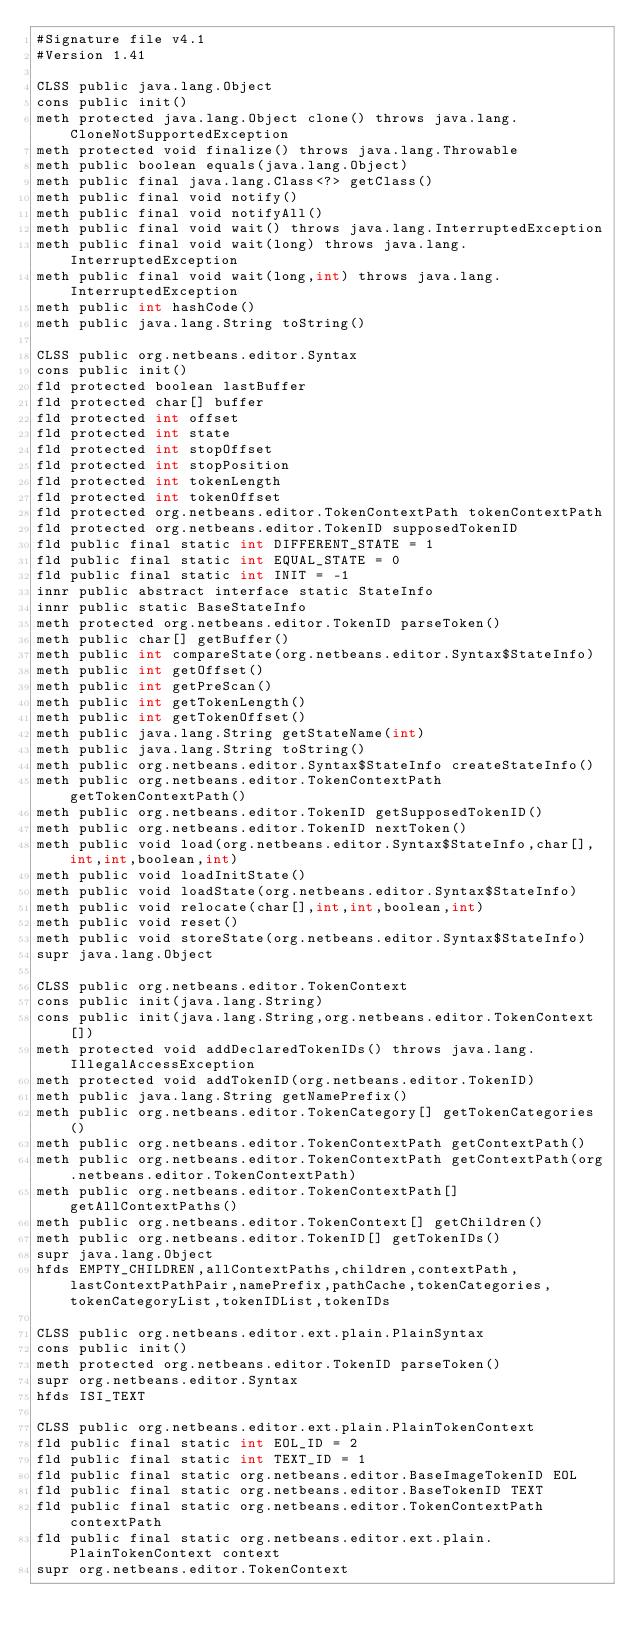Convert code to text. <code><loc_0><loc_0><loc_500><loc_500><_SML_>#Signature file v4.1
#Version 1.41

CLSS public java.lang.Object
cons public init()
meth protected java.lang.Object clone() throws java.lang.CloneNotSupportedException
meth protected void finalize() throws java.lang.Throwable
meth public boolean equals(java.lang.Object)
meth public final java.lang.Class<?> getClass()
meth public final void notify()
meth public final void notifyAll()
meth public final void wait() throws java.lang.InterruptedException
meth public final void wait(long) throws java.lang.InterruptedException
meth public final void wait(long,int) throws java.lang.InterruptedException
meth public int hashCode()
meth public java.lang.String toString()

CLSS public org.netbeans.editor.Syntax
cons public init()
fld protected boolean lastBuffer
fld protected char[] buffer
fld protected int offset
fld protected int state
fld protected int stopOffset
fld protected int stopPosition
fld protected int tokenLength
fld protected int tokenOffset
fld protected org.netbeans.editor.TokenContextPath tokenContextPath
fld protected org.netbeans.editor.TokenID supposedTokenID
fld public final static int DIFFERENT_STATE = 1
fld public final static int EQUAL_STATE = 0
fld public final static int INIT = -1
innr public abstract interface static StateInfo
innr public static BaseStateInfo
meth protected org.netbeans.editor.TokenID parseToken()
meth public char[] getBuffer()
meth public int compareState(org.netbeans.editor.Syntax$StateInfo)
meth public int getOffset()
meth public int getPreScan()
meth public int getTokenLength()
meth public int getTokenOffset()
meth public java.lang.String getStateName(int)
meth public java.lang.String toString()
meth public org.netbeans.editor.Syntax$StateInfo createStateInfo()
meth public org.netbeans.editor.TokenContextPath getTokenContextPath()
meth public org.netbeans.editor.TokenID getSupposedTokenID()
meth public org.netbeans.editor.TokenID nextToken()
meth public void load(org.netbeans.editor.Syntax$StateInfo,char[],int,int,boolean,int)
meth public void loadInitState()
meth public void loadState(org.netbeans.editor.Syntax$StateInfo)
meth public void relocate(char[],int,int,boolean,int)
meth public void reset()
meth public void storeState(org.netbeans.editor.Syntax$StateInfo)
supr java.lang.Object

CLSS public org.netbeans.editor.TokenContext
cons public init(java.lang.String)
cons public init(java.lang.String,org.netbeans.editor.TokenContext[])
meth protected void addDeclaredTokenIDs() throws java.lang.IllegalAccessException
meth protected void addTokenID(org.netbeans.editor.TokenID)
meth public java.lang.String getNamePrefix()
meth public org.netbeans.editor.TokenCategory[] getTokenCategories()
meth public org.netbeans.editor.TokenContextPath getContextPath()
meth public org.netbeans.editor.TokenContextPath getContextPath(org.netbeans.editor.TokenContextPath)
meth public org.netbeans.editor.TokenContextPath[] getAllContextPaths()
meth public org.netbeans.editor.TokenContext[] getChildren()
meth public org.netbeans.editor.TokenID[] getTokenIDs()
supr java.lang.Object
hfds EMPTY_CHILDREN,allContextPaths,children,contextPath,lastContextPathPair,namePrefix,pathCache,tokenCategories,tokenCategoryList,tokenIDList,tokenIDs

CLSS public org.netbeans.editor.ext.plain.PlainSyntax
cons public init()
meth protected org.netbeans.editor.TokenID parseToken()
supr org.netbeans.editor.Syntax
hfds ISI_TEXT

CLSS public org.netbeans.editor.ext.plain.PlainTokenContext
fld public final static int EOL_ID = 2
fld public final static int TEXT_ID = 1
fld public final static org.netbeans.editor.BaseImageTokenID EOL
fld public final static org.netbeans.editor.BaseTokenID TEXT
fld public final static org.netbeans.editor.TokenContextPath contextPath
fld public final static org.netbeans.editor.ext.plain.PlainTokenContext context
supr org.netbeans.editor.TokenContext

</code> 